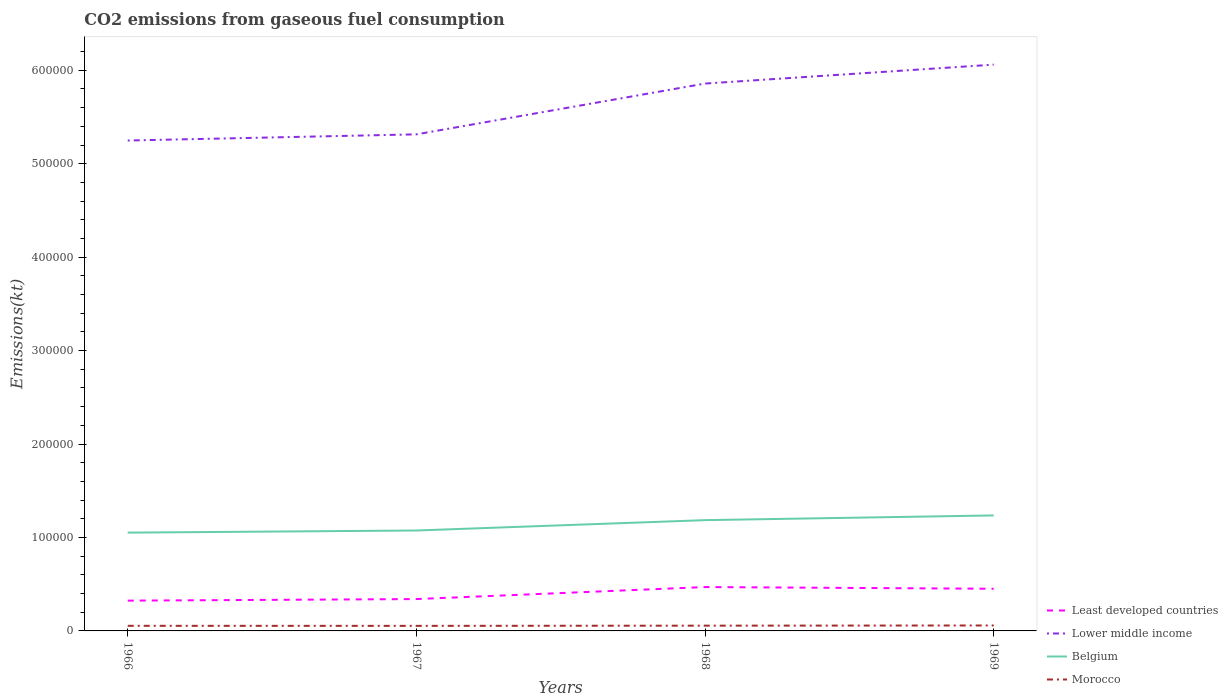How many different coloured lines are there?
Give a very brief answer. 4. Does the line corresponding to Least developed countries intersect with the line corresponding to Morocco?
Make the answer very short. No. Across all years, what is the maximum amount of CO2 emitted in Least developed countries?
Provide a short and direct response. 3.24e+04. In which year was the amount of CO2 emitted in Morocco maximum?
Provide a short and direct response. 1967. What is the total amount of CO2 emitted in Lower middle income in the graph?
Provide a succinct answer. -6.10e+04. What is the difference between the highest and the second highest amount of CO2 emitted in Morocco?
Your response must be concise. 410.7. Is the amount of CO2 emitted in Belgium strictly greater than the amount of CO2 emitted in Morocco over the years?
Give a very brief answer. No. How many lines are there?
Ensure brevity in your answer.  4. Does the graph contain grids?
Offer a terse response. No. Where does the legend appear in the graph?
Your response must be concise. Bottom right. How are the legend labels stacked?
Your answer should be compact. Vertical. What is the title of the graph?
Your response must be concise. CO2 emissions from gaseous fuel consumption. What is the label or title of the Y-axis?
Offer a very short reply. Emissions(kt). What is the Emissions(kt) in Least developed countries in 1966?
Provide a succinct answer. 3.24e+04. What is the Emissions(kt) in Lower middle income in 1966?
Make the answer very short. 5.25e+05. What is the Emissions(kt) in Belgium in 1966?
Offer a terse response. 1.05e+05. What is the Emissions(kt) in Morocco in 1966?
Provide a short and direct response. 5467.5. What is the Emissions(kt) in Least developed countries in 1967?
Offer a terse response. 3.41e+04. What is the Emissions(kt) of Lower middle income in 1967?
Your response must be concise. 5.31e+05. What is the Emissions(kt) in Belgium in 1967?
Provide a short and direct response. 1.07e+05. What is the Emissions(kt) of Morocco in 1967?
Ensure brevity in your answer.  5416.16. What is the Emissions(kt) in Least developed countries in 1968?
Offer a terse response. 4.69e+04. What is the Emissions(kt) in Lower middle income in 1968?
Your answer should be very brief. 5.86e+05. What is the Emissions(kt) of Belgium in 1968?
Your answer should be compact. 1.19e+05. What is the Emissions(kt) in Morocco in 1968?
Ensure brevity in your answer.  5628.85. What is the Emissions(kt) of Least developed countries in 1969?
Keep it short and to the point. 4.51e+04. What is the Emissions(kt) of Lower middle income in 1969?
Your response must be concise. 6.06e+05. What is the Emissions(kt) in Belgium in 1969?
Ensure brevity in your answer.  1.24e+05. What is the Emissions(kt) of Morocco in 1969?
Provide a succinct answer. 5826.86. Across all years, what is the maximum Emissions(kt) in Least developed countries?
Give a very brief answer. 4.69e+04. Across all years, what is the maximum Emissions(kt) in Lower middle income?
Ensure brevity in your answer.  6.06e+05. Across all years, what is the maximum Emissions(kt) in Belgium?
Provide a short and direct response. 1.24e+05. Across all years, what is the maximum Emissions(kt) of Morocco?
Your answer should be compact. 5826.86. Across all years, what is the minimum Emissions(kt) in Least developed countries?
Ensure brevity in your answer.  3.24e+04. Across all years, what is the minimum Emissions(kt) of Lower middle income?
Keep it short and to the point. 5.25e+05. Across all years, what is the minimum Emissions(kt) of Belgium?
Provide a succinct answer. 1.05e+05. Across all years, what is the minimum Emissions(kt) of Morocco?
Provide a succinct answer. 5416.16. What is the total Emissions(kt) of Least developed countries in the graph?
Offer a terse response. 1.59e+05. What is the total Emissions(kt) of Lower middle income in the graph?
Offer a terse response. 2.25e+06. What is the total Emissions(kt) of Belgium in the graph?
Provide a short and direct response. 4.55e+05. What is the total Emissions(kt) in Morocco in the graph?
Your answer should be compact. 2.23e+04. What is the difference between the Emissions(kt) in Least developed countries in 1966 and that in 1967?
Offer a terse response. -1675.37. What is the difference between the Emissions(kt) of Lower middle income in 1966 and that in 1967?
Your answer should be compact. -6604.4. What is the difference between the Emissions(kt) in Belgium in 1966 and that in 1967?
Provide a short and direct response. -2266.21. What is the difference between the Emissions(kt) of Morocco in 1966 and that in 1967?
Your response must be concise. 51.34. What is the difference between the Emissions(kt) in Least developed countries in 1966 and that in 1968?
Your answer should be very brief. -1.45e+04. What is the difference between the Emissions(kt) of Lower middle income in 1966 and that in 1968?
Provide a succinct answer. -6.10e+04. What is the difference between the Emissions(kt) of Belgium in 1966 and that in 1968?
Offer a very short reply. -1.34e+04. What is the difference between the Emissions(kt) in Morocco in 1966 and that in 1968?
Ensure brevity in your answer.  -161.35. What is the difference between the Emissions(kt) of Least developed countries in 1966 and that in 1969?
Give a very brief answer. -1.27e+04. What is the difference between the Emissions(kt) in Lower middle income in 1966 and that in 1969?
Your answer should be very brief. -8.12e+04. What is the difference between the Emissions(kt) in Belgium in 1966 and that in 1969?
Offer a very short reply. -1.84e+04. What is the difference between the Emissions(kt) of Morocco in 1966 and that in 1969?
Keep it short and to the point. -359.37. What is the difference between the Emissions(kt) in Least developed countries in 1967 and that in 1968?
Keep it short and to the point. -1.29e+04. What is the difference between the Emissions(kt) of Lower middle income in 1967 and that in 1968?
Offer a terse response. -5.44e+04. What is the difference between the Emissions(kt) of Belgium in 1967 and that in 1968?
Your response must be concise. -1.11e+04. What is the difference between the Emissions(kt) of Morocco in 1967 and that in 1968?
Your answer should be compact. -212.69. What is the difference between the Emissions(kt) of Least developed countries in 1967 and that in 1969?
Ensure brevity in your answer.  -1.10e+04. What is the difference between the Emissions(kt) of Lower middle income in 1967 and that in 1969?
Your response must be concise. -7.46e+04. What is the difference between the Emissions(kt) of Belgium in 1967 and that in 1969?
Your answer should be very brief. -1.61e+04. What is the difference between the Emissions(kt) of Morocco in 1967 and that in 1969?
Provide a short and direct response. -410.7. What is the difference between the Emissions(kt) in Least developed countries in 1968 and that in 1969?
Provide a succinct answer. 1823.83. What is the difference between the Emissions(kt) of Lower middle income in 1968 and that in 1969?
Provide a succinct answer. -2.03e+04. What is the difference between the Emissions(kt) of Belgium in 1968 and that in 1969?
Your answer should be very brief. -5060.46. What is the difference between the Emissions(kt) of Morocco in 1968 and that in 1969?
Your answer should be very brief. -198.02. What is the difference between the Emissions(kt) in Least developed countries in 1966 and the Emissions(kt) in Lower middle income in 1967?
Your answer should be compact. -4.99e+05. What is the difference between the Emissions(kt) of Least developed countries in 1966 and the Emissions(kt) of Belgium in 1967?
Your answer should be compact. -7.51e+04. What is the difference between the Emissions(kt) of Least developed countries in 1966 and the Emissions(kt) of Morocco in 1967?
Ensure brevity in your answer.  2.70e+04. What is the difference between the Emissions(kt) of Lower middle income in 1966 and the Emissions(kt) of Belgium in 1967?
Offer a terse response. 4.17e+05. What is the difference between the Emissions(kt) in Lower middle income in 1966 and the Emissions(kt) in Morocco in 1967?
Offer a very short reply. 5.19e+05. What is the difference between the Emissions(kt) of Belgium in 1966 and the Emissions(kt) of Morocco in 1967?
Make the answer very short. 9.98e+04. What is the difference between the Emissions(kt) of Least developed countries in 1966 and the Emissions(kt) of Lower middle income in 1968?
Your response must be concise. -5.53e+05. What is the difference between the Emissions(kt) in Least developed countries in 1966 and the Emissions(kt) in Belgium in 1968?
Offer a very short reply. -8.61e+04. What is the difference between the Emissions(kt) in Least developed countries in 1966 and the Emissions(kt) in Morocco in 1968?
Your response must be concise. 2.68e+04. What is the difference between the Emissions(kt) in Lower middle income in 1966 and the Emissions(kt) in Belgium in 1968?
Give a very brief answer. 4.06e+05. What is the difference between the Emissions(kt) in Lower middle income in 1966 and the Emissions(kt) in Morocco in 1968?
Make the answer very short. 5.19e+05. What is the difference between the Emissions(kt) in Belgium in 1966 and the Emissions(kt) in Morocco in 1968?
Give a very brief answer. 9.96e+04. What is the difference between the Emissions(kt) of Least developed countries in 1966 and the Emissions(kt) of Lower middle income in 1969?
Provide a succinct answer. -5.74e+05. What is the difference between the Emissions(kt) of Least developed countries in 1966 and the Emissions(kt) of Belgium in 1969?
Ensure brevity in your answer.  -9.12e+04. What is the difference between the Emissions(kt) of Least developed countries in 1966 and the Emissions(kt) of Morocco in 1969?
Your answer should be very brief. 2.66e+04. What is the difference between the Emissions(kt) of Lower middle income in 1966 and the Emissions(kt) of Belgium in 1969?
Ensure brevity in your answer.  4.01e+05. What is the difference between the Emissions(kt) of Lower middle income in 1966 and the Emissions(kt) of Morocco in 1969?
Give a very brief answer. 5.19e+05. What is the difference between the Emissions(kt) of Belgium in 1966 and the Emissions(kt) of Morocco in 1969?
Offer a terse response. 9.94e+04. What is the difference between the Emissions(kt) of Least developed countries in 1967 and the Emissions(kt) of Lower middle income in 1968?
Ensure brevity in your answer.  -5.52e+05. What is the difference between the Emissions(kt) in Least developed countries in 1967 and the Emissions(kt) in Belgium in 1968?
Your answer should be compact. -8.45e+04. What is the difference between the Emissions(kt) of Least developed countries in 1967 and the Emissions(kt) of Morocco in 1968?
Give a very brief answer. 2.85e+04. What is the difference between the Emissions(kt) in Lower middle income in 1967 and the Emissions(kt) in Belgium in 1968?
Ensure brevity in your answer.  4.13e+05. What is the difference between the Emissions(kt) in Lower middle income in 1967 and the Emissions(kt) in Morocco in 1968?
Offer a terse response. 5.26e+05. What is the difference between the Emissions(kt) of Belgium in 1967 and the Emissions(kt) of Morocco in 1968?
Make the answer very short. 1.02e+05. What is the difference between the Emissions(kt) of Least developed countries in 1967 and the Emissions(kt) of Lower middle income in 1969?
Give a very brief answer. -5.72e+05. What is the difference between the Emissions(kt) in Least developed countries in 1967 and the Emissions(kt) in Belgium in 1969?
Keep it short and to the point. -8.95e+04. What is the difference between the Emissions(kt) of Least developed countries in 1967 and the Emissions(kt) of Morocco in 1969?
Your answer should be compact. 2.83e+04. What is the difference between the Emissions(kt) in Lower middle income in 1967 and the Emissions(kt) in Belgium in 1969?
Give a very brief answer. 4.08e+05. What is the difference between the Emissions(kt) of Lower middle income in 1967 and the Emissions(kt) of Morocco in 1969?
Your answer should be very brief. 5.26e+05. What is the difference between the Emissions(kt) in Belgium in 1967 and the Emissions(kt) in Morocco in 1969?
Your answer should be compact. 1.02e+05. What is the difference between the Emissions(kt) of Least developed countries in 1968 and the Emissions(kt) of Lower middle income in 1969?
Your response must be concise. -5.59e+05. What is the difference between the Emissions(kt) of Least developed countries in 1968 and the Emissions(kt) of Belgium in 1969?
Your answer should be compact. -7.67e+04. What is the difference between the Emissions(kt) of Least developed countries in 1968 and the Emissions(kt) of Morocco in 1969?
Keep it short and to the point. 4.11e+04. What is the difference between the Emissions(kt) in Lower middle income in 1968 and the Emissions(kt) in Belgium in 1969?
Offer a very short reply. 4.62e+05. What is the difference between the Emissions(kt) in Lower middle income in 1968 and the Emissions(kt) in Morocco in 1969?
Your response must be concise. 5.80e+05. What is the difference between the Emissions(kt) in Belgium in 1968 and the Emissions(kt) in Morocco in 1969?
Make the answer very short. 1.13e+05. What is the average Emissions(kt) of Least developed countries per year?
Make the answer very short. 3.96e+04. What is the average Emissions(kt) in Lower middle income per year?
Make the answer very short. 5.62e+05. What is the average Emissions(kt) in Belgium per year?
Offer a very short reply. 1.14e+05. What is the average Emissions(kt) of Morocco per year?
Offer a very short reply. 5584.84. In the year 1966, what is the difference between the Emissions(kt) of Least developed countries and Emissions(kt) of Lower middle income?
Ensure brevity in your answer.  -4.92e+05. In the year 1966, what is the difference between the Emissions(kt) in Least developed countries and Emissions(kt) in Belgium?
Provide a short and direct response. -7.28e+04. In the year 1966, what is the difference between the Emissions(kt) of Least developed countries and Emissions(kt) of Morocco?
Your response must be concise. 2.69e+04. In the year 1966, what is the difference between the Emissions(kt) of Lower middle income and Emissions(kt) of Belgium?
Keep it short and to the point. 4.20e+05. In the year 1966, what is the difference between the Emissions(kt) in Lower middle income and Emissions(kt) in Morocco?
Your answer should be very brief. 5.19e+05. In the year 1966, what is the difference between the Emissions(kt) in Belgium and Emissions(kt) in Morocco?
Your response must be concise. 9.97e+04. In the year 1967, what is the difference between the Emissions(kt) of Least developed countries and Emissions(kt) of Lower middle income?
Your response must be concise. -4.97e+05. In the year 1967, what is the difference between the Emissions(kt) of Least developed countries and Emissions(kt) of Belgium?
Offer a terse response. -7.34e+04. In the year 1967, what is the difference between the Emissions(kt) of Least developed countries and Emissions(kt) of Morocco?
Provide a succinct answer. 2.87e+04. In the year 1967, what is the difference between the Emissions(kt) of Lower middle income and Emissions(kt) of Belgium?
Your answer should be very brief. 4.24e+05. In the year 1967, what is the difference between the Emissions(kt) in Lower middle income and Emissions(kt) in Morocco?
Your answer should be very brief. 5.26e+05. In the year 1967, what is the difference between the Emissions(kt) of Belgium and Emissions(kt) of Morocco?
Provide a short and direct response. 1.02e+05. In the year 1968, what is the difference between the Emissions(kt) of Least developed countries and Emissions(kt) of Lower middle income?
Your response must be concise. -5.39e+05. In the year 1968, what is the difference between the Emissions(kt) of Least developed countries and Emissions(kt) of Belgium?
Offer a very short reply. -7.16e+04. In the year 1968, what is the difference between the Emissions(kt) in Least developed countries and Emissions(kt) in Morocco?
Make the answer very short. 4.13e+04. In the year 1968, what is the difference between the Emissions(kt) of Lower middle income and Emissions(kt) of Belgium?
Ensure brevity in your answer.  4.67e+05. In the year 1968, what is the difference between the Emissions(kt) of Lower middle income and Emissions(kt) of Morocco?
Provide a short and direct response. 5.80e+05. In the year 1968, what is the difference between the Emissions(kt) in Belgium and Emissions(kt) in Morocco?
Ensure brevity in your answer.  1.13e+05. In the year 1969, what is the difference between the Emissions(kt) in Least developed countries and Emissions(kt) in Lower middle income?
Offer a very short reply. -5.61e+05. In the year 1969, what is the difference between the Emissions(kt) of Least developed countries and Emissions(kt) of Belgium?
Provide a short and direct response. -7.85e+04. In the year 1969, what is the difference between the Emissions(kt) of Least developed countries and Emissions(kt) of Morocco?
Offer a terse response. 3.93e+04. In the year 1969, what is the difference between the Emissions(kt) in Lower middle income and Emissions(kt) in Belgium?
Your answer should be very brief. 4.82e+05. In the year 1969, what is the difference between the Emissions(kt) in Lower middle income and Emissions(kt) in Morocco?
Ensure brevity in your answer.  6.00e+05. In the year 1969, what is the difference between the Emissions(kt) in Belgium and Emissions(kt) in Morocco?
Offer a terse response. 1.18e+05. What is the ratio of the Emissions(kt) of Least developed countries in 1966 to that in 1967?
Offer a very short reply. 0.95. What is the ratio of the Emissions(kt) of Lower middle income in 1966 to that in 1967?
Offer a terse response. 0.99. What is the ratio of the Emissions(kt) in Belgium in 1966 to that in 1967?
Provide a short and direct response. 0.98. What is the ratio of the Emissions(kt) of Morocco in 1966 to that in 1967?
Make the answer very short. 1.01. What is the ratio of the Emissions(kt) of Least developed countries in 1966 to that in 1968?
Your answer should be compact. 0.69. What is the ratio of the Emissions(kt) in Lower middle income in 1966 to that in 1968?
Provide a short and direct response. 0.9. What is the ratio of the Emissions(kt) in Belgium in 1966 to that in 1968?
Your response must be concise. 0.89. What is the ratio of the Emissions(kt) of Morocco in 1966 to that in 1968?
Your answer should be compact. 0.97. What is the ratio of the Emissions(kt) in Least developed countries in 1966 to that in 1969?
Make the answer very short. 0.72. What is the ratio of the Emissions(kt) of Lower middle income in 1966 to that in 1969?
Ensure brevity in your answer.  0.87. What is the ratio of the Emissions(kt) in Belgium in 1966 to that in 1969?
Make the answer very short. 0.85. What is the ratio of the Emissions(kt) of Morocco in 1966 to that in 1969?
Your answer should be compact. 0.94. What is the ratio of the Emissions(kt) of Least developed countries in 1967 to that in 1968?
Keep it short and to the point. 0.73. What is the ratio of the Emissions(kt) of Lower middle income in 1967 to that in 1968?
Keep it short and to the point. 0.91. What is the ratio of the Emissions(kt) in Belgium in 1967 to that in 1968?
Ensure brevity in your answer.  0.91. What is the ratio of the Emissions(kt) in Morocco in 1967 to that in 1968?
Make the answer very short. 0.96. What is the ratio of the Emissions(kt) in Least developed countries in 1967 to that in 1969?
Keep it short and to the point. 0.76. What is the ratio of the Emissions(kt) in Lower middle income in 1967 to that in 1969?
Provide a succinct answer. 0.88. What is the ratio of the Emissions(kt) in Belgium in 1967 to that in 1969?
Provide a short and direct response. 0.87. What is the ratio of the Emissions(kt) in Morocco in 1967 to that in 1969?
Provide a short and direct response. 0.93. What is the ratio of the Emissions(kt) in Least developed countries in 1968 to that in 1969?
Make the answer very short. 1.04. What is the ratio of the Emissions(kt) of Lower middle income in 1968 to that in 1969?
Provide a short and direct response. 0.97. What is the ratio of the Emissions(kt) of Belgium in 1968 to that in 1969?
Offer a very short reply. 0.96. What is the ratio of the Emissions(kt) in Morocco in 1968 to that in 1969?
Your response must be concise. 0.97. What is the difference between the highest and the second highest Emissions(kt) in Least developed countries?
Make the answer very short. 1823.83. What is the difference between the highest and the second highest Emissions(kt) in Lower middle income?
Offer a terse response. 2.03e+04. What is the difference between the highest and the second highest Emissions(kt) in Belgium?
Offer a terse response. 5060.46. What is the difference between the highest and the second highest Emissions(kt) of Morocco?
Provide a succinct answer. 198.02. What is the difference between the highest and the lowest Emissions(kt) of Least developed countries?
Offer a terse response. 1.45e+04. What is the difference between the highest and the lowest Emissions(kt) in Lower middle income?
Ensure brevity in your answer.  8.12e+04. What is the difference between the highest and the lowest Emissions(kt) of Belgium?
Keep it short and to the point. 1.84e+04. What is the difference between the highest and the lowest Emissions(kt) in Morocco?
Provide a short and direct response. 410.7. 